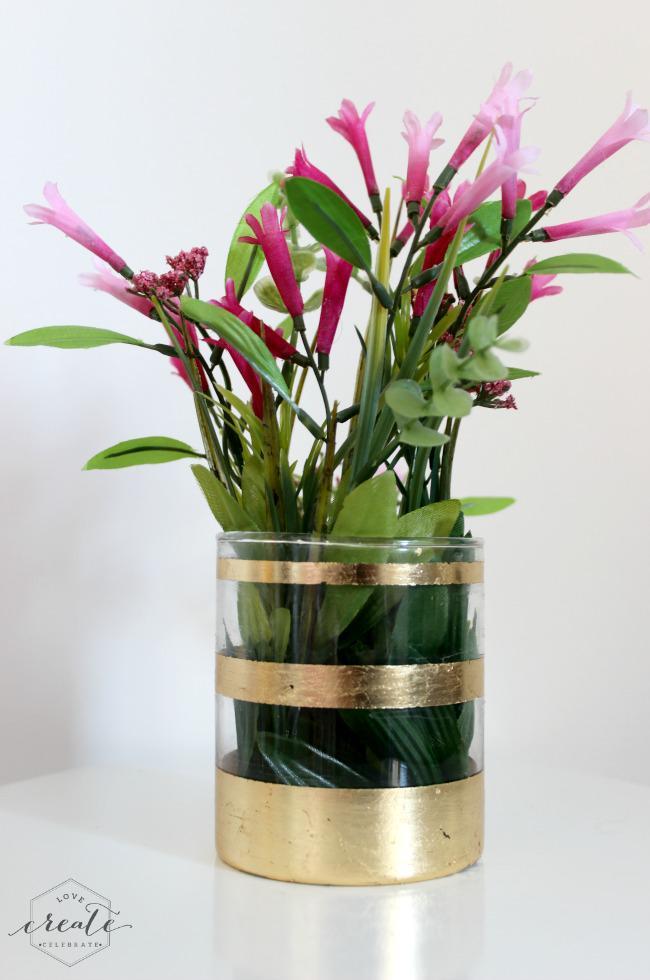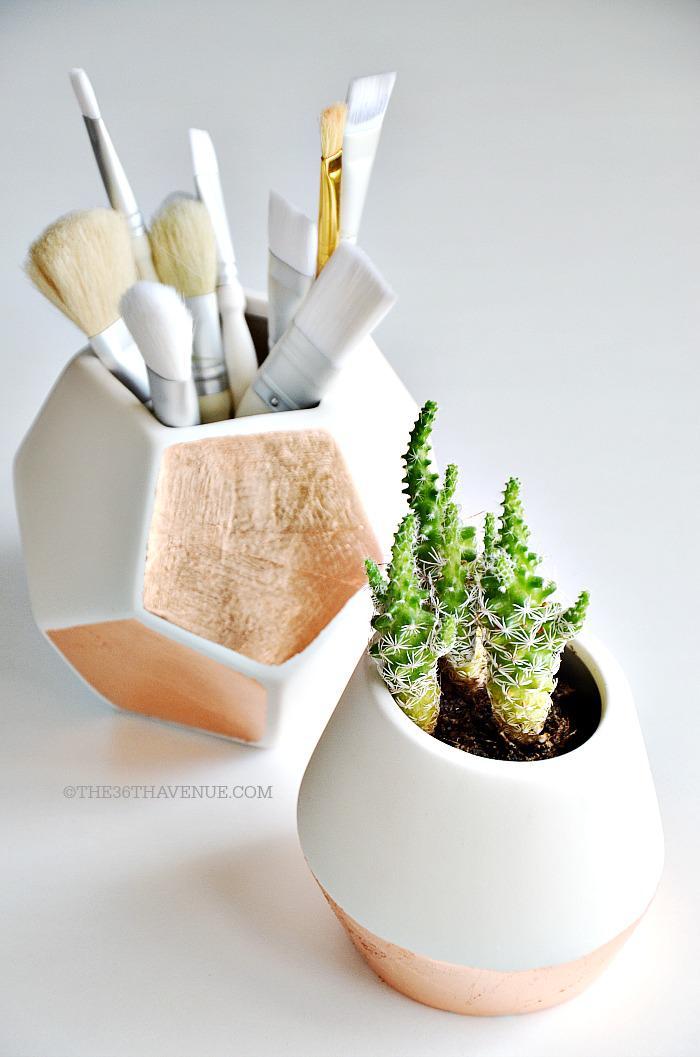The first image is the image on the left, the second image is the image on the right. Evaluate the accuracy of this statement regarding the images: "Several plants sit in vases in the image on the right.". Is it true? Answer yes or no. No. The first image is the image on the left, the second image is the image on the right. Given the left and right images, does the statement "At least one planter has a succulent in it." hold true? Answer yes or no. Yes. 